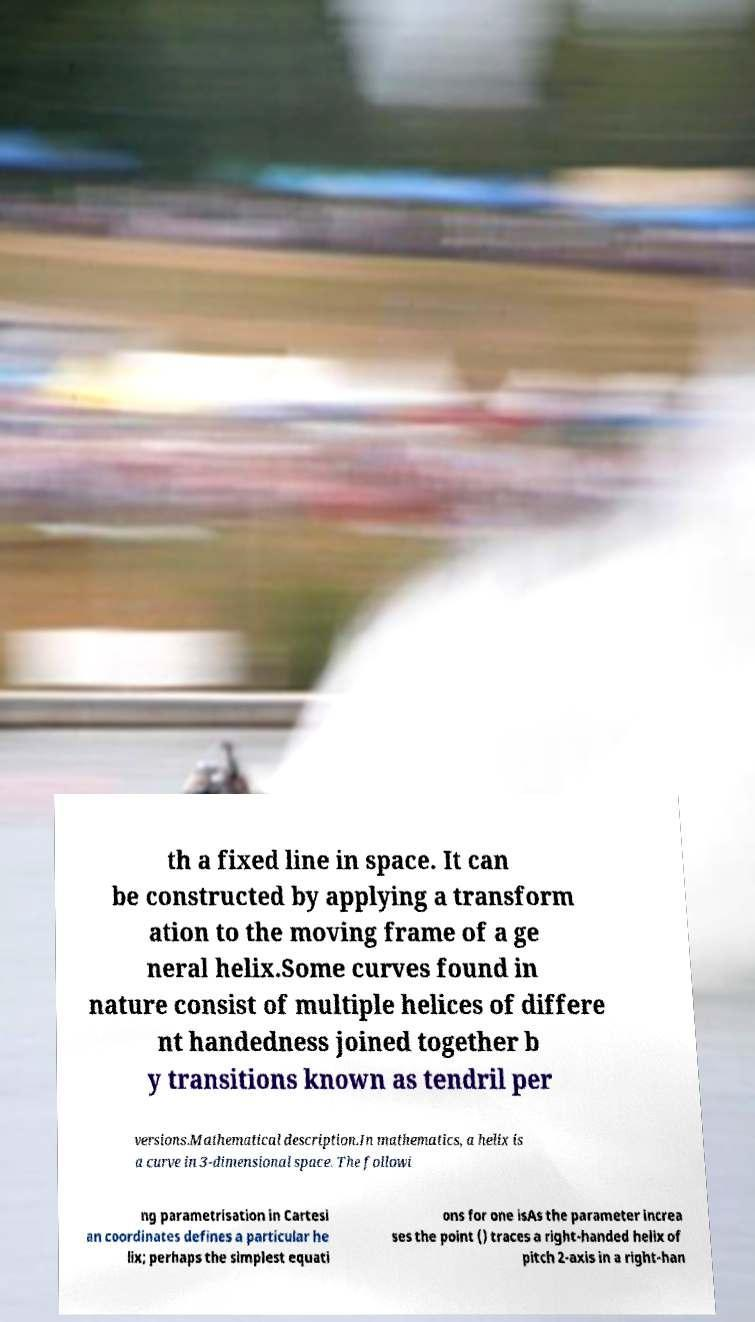Could you extract and type out the text from this image? th a fixed line in space. It can be constructed by applying a transform ation to the moving frame of a ge neral helix.Some curves found in nature consist of multiple helices of differe nt handedness joined together b y transitions known as tendril per versions.Mathematical description.In mathematics, a helix is a curve in 3-dimensional space. The followi ng parametrisation in Cartesi an coordinates defines a particular he lix; perhaps the simplest equati ons for one isAs the parameter increa ses the point () traces a right-handed helix of pitch 2-axis in a right-han 